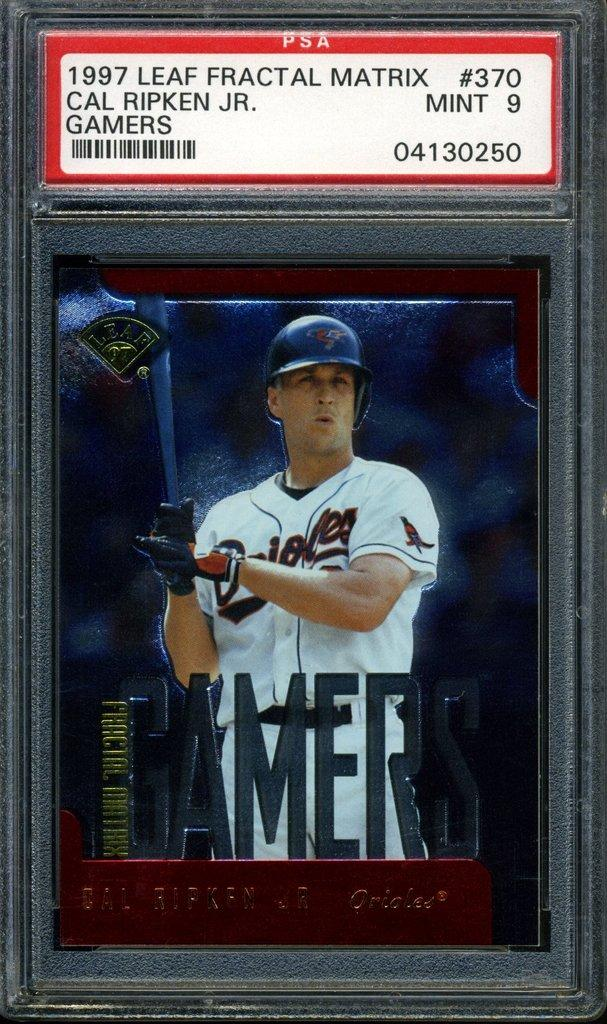<image>
Relay a brief, clear account of the picture shown. A 1997 Leaf Fractal Matrix baseball card for Cal Ripken Junior. 